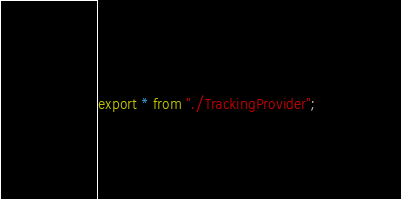<code> <loc_0><loc_0><loc_500><loc_500><_TypeScript_>export * from "./TrackingProvider";</code> 